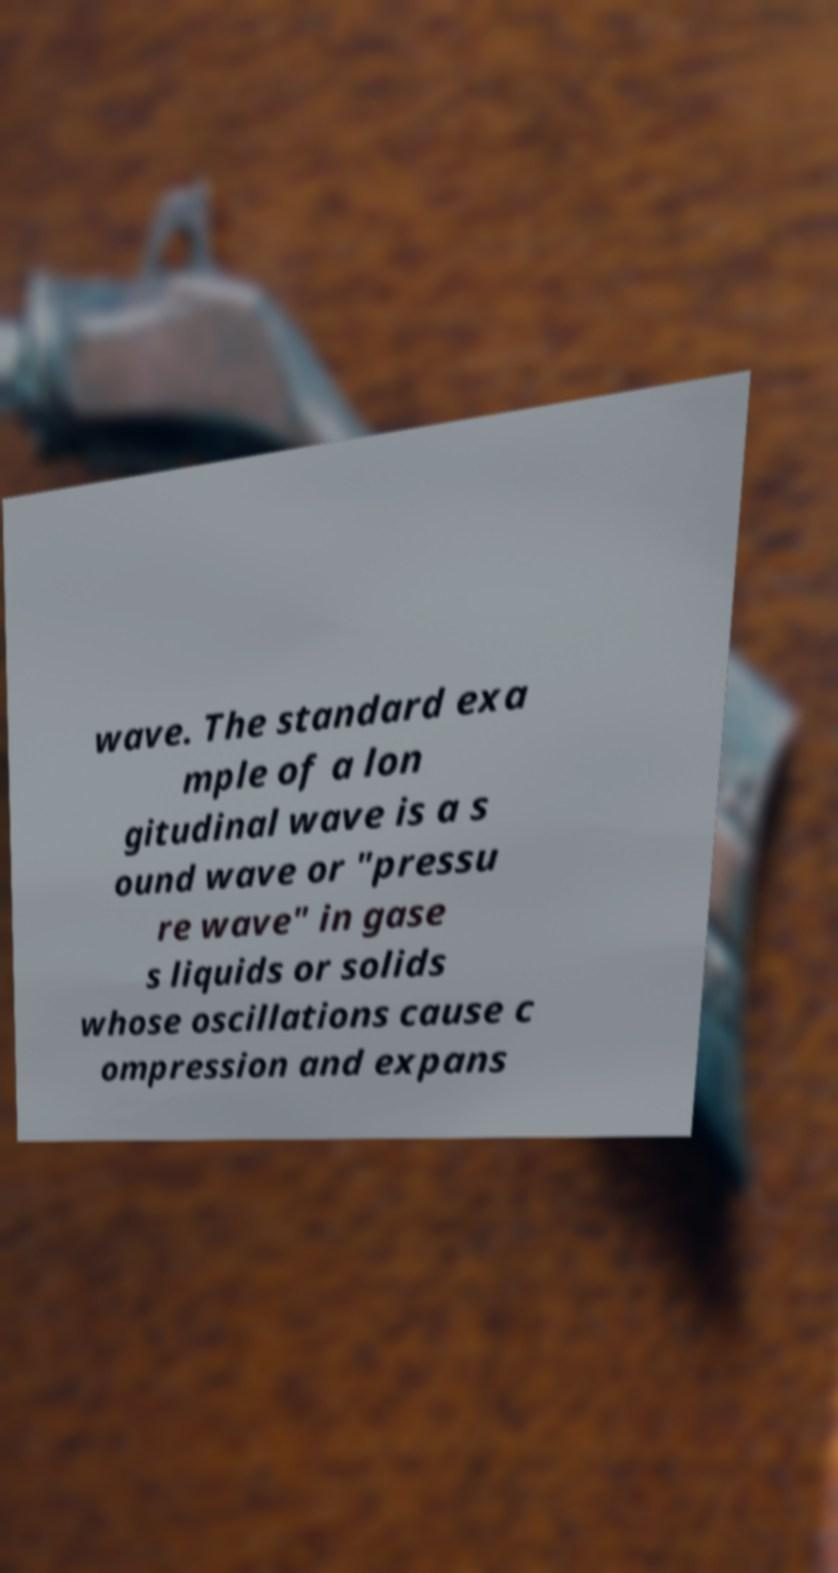Can you read and provide the text displayed in the image?This photo seems to have some interesting text. Can you extract and type it out for me? wave. The standard exa mple of a lon gitudinal wave is a s ound wave or "pressu re wave" in gase s liquids or solids whose oscillations cause c ompression and expans 